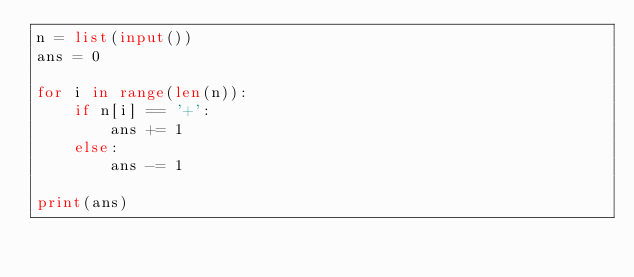Convert code to text. <code><loc_0><loc_0><loc_500><loc_500><_Python_>n = list(input())
ans = 0

for i in range(len(n)):
    if n[i] == '+':
        ans += 1
    else:
        ans -= 1

print(ans)</code> 